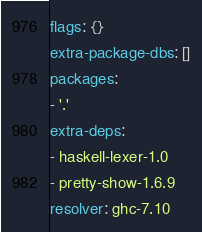Convert code to text. <code><loc_0><loc_0><loc_500><loc_500><_YAML_>flags: {}
extra-package-dbs: []
packages:
- '.'
extra-deps:
- haskell-lexer-1.0
- pretty-show-1.6.9
resolver: ghc-7.10
</code> 